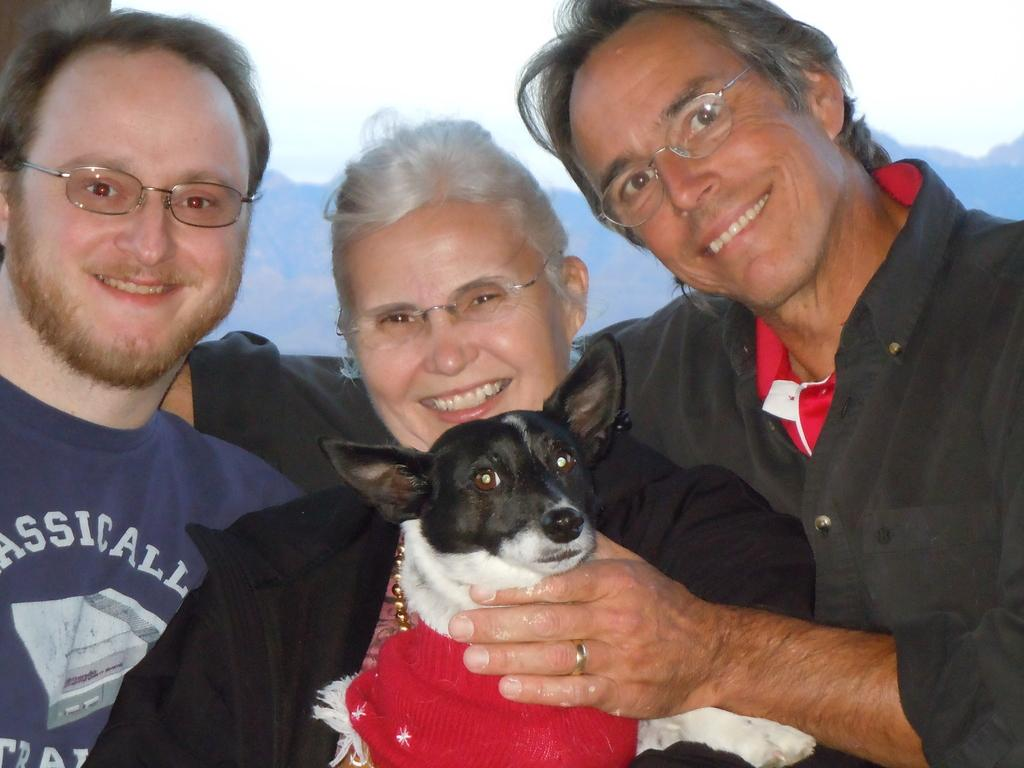How many people are present in the image? There are three individuals in the image: two men and one woman. What are the three individuals doing in the image? The three individuals are holding a dog. What type of pencil is the parent using to draw in the image? There is no pencil or drawing activity present in the image. What kind of music is the band playing in the image? There is no band or music playing in the image. 